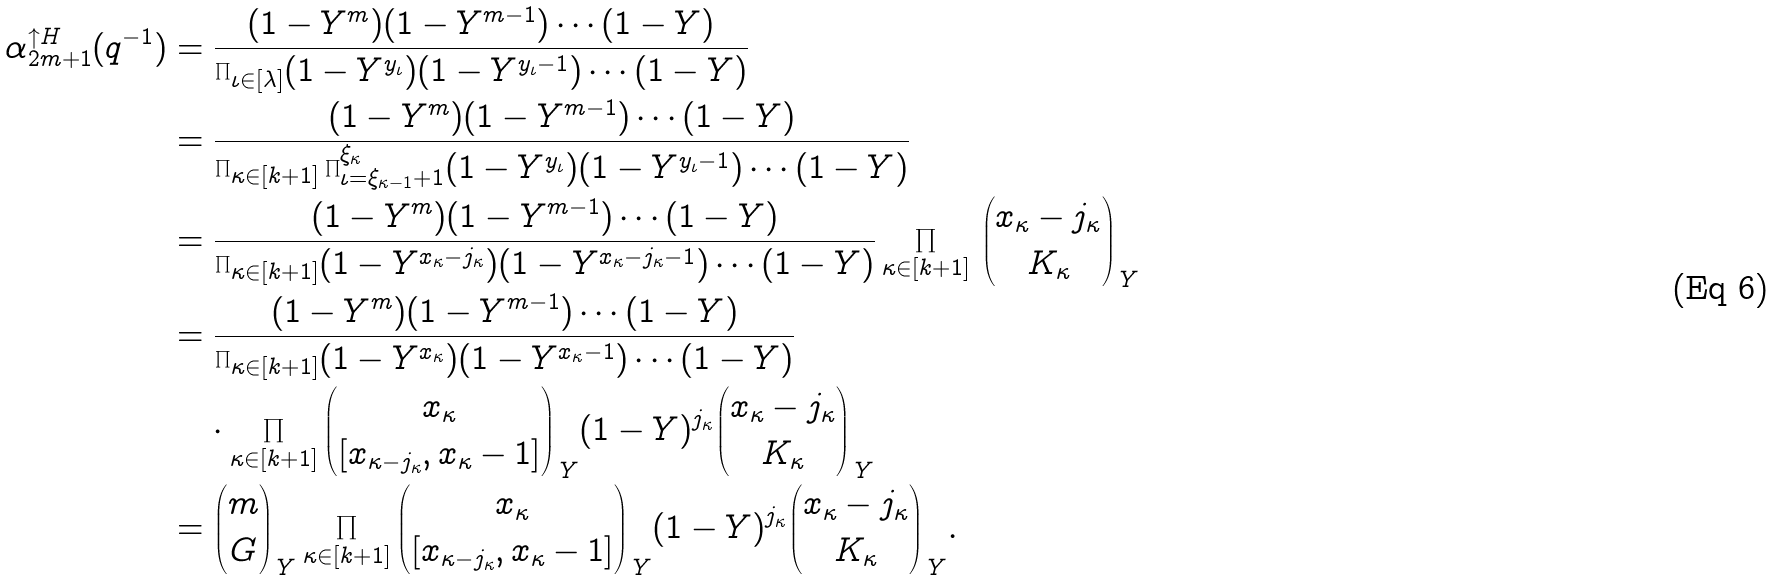<formula> <loc_0><loc_0><loc_500><loc_500>\alpha _ { 2 m + 1 } ^ { \uparrow H } ( q ^ { - 1 } ) & = \frac { ( 1 - Y ^ { m } ) ( 1 - Y ^ { m - 1 } ) \cdots ( 1 - Y ) } { \prod _ { \iota \in [ \lambda ] } ( 1 - Y ^ { y _ { \iota } } ) ( 1 - Y ^ { y _ { \iota } - 1 } ) \cdots ( 1 - Y ) } \\ & = \frac { ( 1 - Y ^ { m } ) ( 1 - Y ^ { m - 1 } ) \cdots ( 1 - Y ) } { \prod _ { \kappa \in [ k + 1 ] } \prod _ { \iota = \xi _ { \kappa - 1 } + 1 } ^ { \xi _ { \kappa } } ( 1 - Y ^ { y _ { \iota } } ) ( 1 - Y ^ { y _ { \iota } - 1 } ) \cdots ( 1 - Y ) } \\ & = \frac { ( 1 - Y ^ { m } ) ( 1 - Y ^ { m - 1 } ) \cdots ( 1 - Y ) } { \prod _ { \kappa \in [ k + 1 ] } ( 1 - Y ^ { x _ { \kappa } - j _ { \kappa } } ) ( 1 - Y ^ { x _ { \kappa } - j _ { \kappa } - 1 } ) \cdots ( 1 - Y ) } \prod _ { \kappa \in [ k + 1 ] } \, \binom { x _ { \kappa } - j _ { \kappa } } { K _ { \kappa } } _ { \, Y } \\ & = \frac { ( 1 - Y ^ { m } ) ( 1 - Y ^ { m - 1 } ) \cdots ( 1 - Y ) } { \prod _ { \kappa \in [ k + 1 ] } ( 1 - Y ^ { x _ { \kappa } } ) ( 1 - Y ^ { x _ { \kappa } - 1 } ) \cdots ( 1 - Y ) } \\ & \quad \cdot \prod _ { \kappa \in [ k + 1 ] } \binom { x _ { \kappa } } { [ x _ { \kappa - j _ { \kappa } } , x _ { \kappa } - 1 ] } _ { \, Y } ( 1 - Y ) ^ { j _ { \kappa } } \binom { x _ { \kappa } - j _ { \kappa } } { K _ { \kappa } } _ { \, Y } \\ & = \binom { m } { G } _ { \, Y } \prod _ { \kappa \in [ k + 1 ] } \binom { x _ { \kappa } } { [ x _ { \kappa - j _ { \kappa } } , x _ { \kappa } - 1 ] } _ { \, Y } ( 1 - Y ) ^ { j _ { \kappa } } \binom { x _ { \kappa } - j _ { \kappa } } { K _ { \kappa } } _ { \, Y } .</formula> 